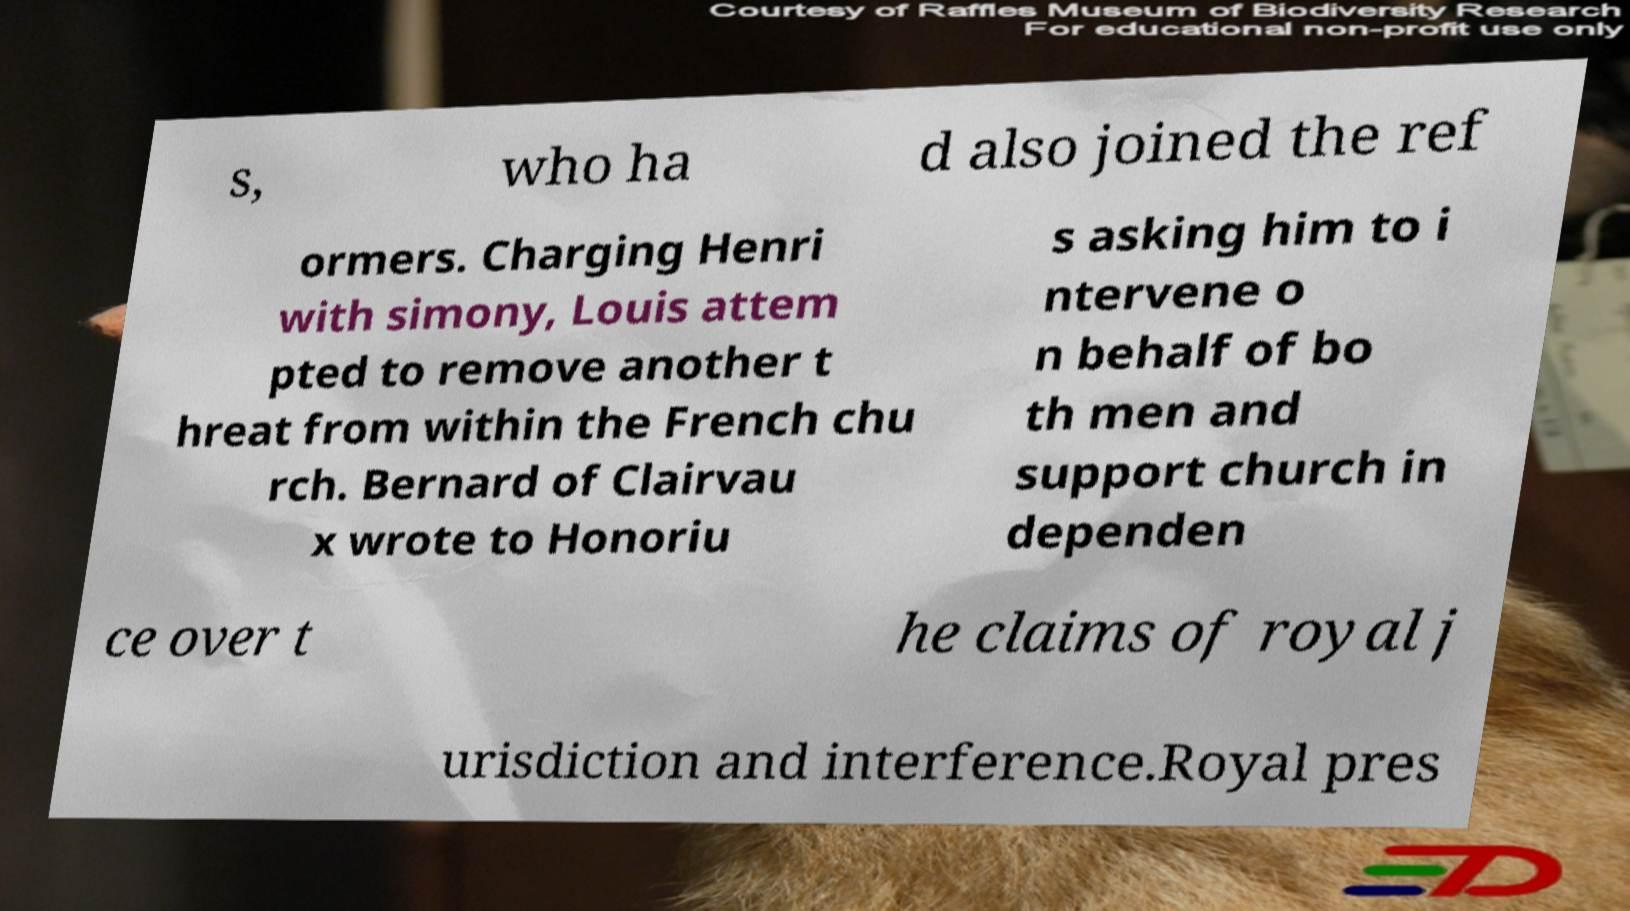Please read and relay the text visible in this image. What does it say? s, who ha d also joined the ref ormers. Charging Henri with simony, Louis attem pted to remove another t hreat from within the French chu rch. Bernard of Clairvau x wrote to Honoriu s asking him to i ntervene o n behalf of bo th men and support church in dependen ce over t he claims of royal j urisdiction and interference.Royal pres 